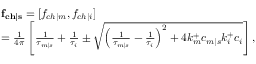<formula> <loc_0><loc_0><loc_500><loc_500>\begin{array} { r l } & { f _ { c h | s } = [ f _ { c h | m } , f _ { c h | i } ] } \\ & { = \frac { 1 } { 4 \pi } \left [ \frac { 1 } { \tau _ { m | s } } + \frac { 1 } { \tau _ { i } } \pm \sqrt { \left ( \frac { 1 } { \tau _ { m | s } } - \frac { 1 } { \tau _ { i } } \right ) ^ { 2 } + 4 k _ { m } ^ { + } c _ { m | s } k _ { i } ^ { + } c _ { i } } \right ] , } \end{array}</formula> 